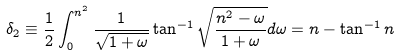<formula> <loc_0><loc_0><loc_500><loc_500>\delta _ { 2 } \equiv \frac { 1 } { 2 } \int _ { 0 } ^ { n ^ { 2 } } \frac { 1 } { \sqrt { 1 + \omega } } \tan ^ { - 1 } { \sqrt { \frac { n ^ { 2 } - \omega } { 1 + \omega } } } d \omega = n - \tan ^ { - 1 } { n }</formula> 